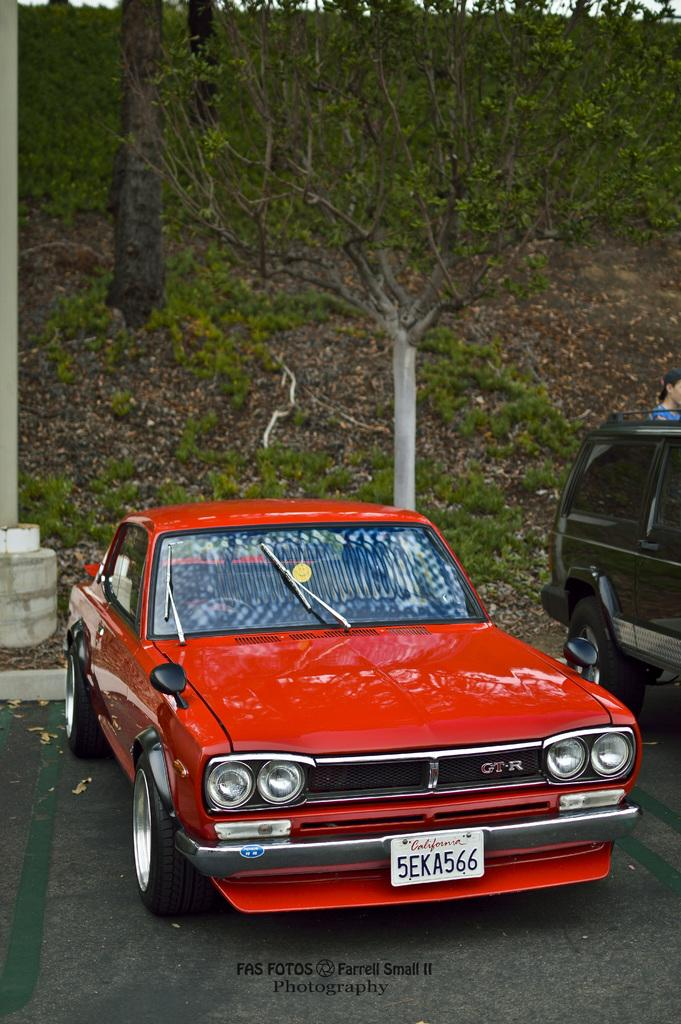What type of vehicle is in the image? There is a red color car in the image. Can you describe the car's color? The car is red. What can be seen in the background of the image? There are trees in the background of the image. What is present at the bottom of the image? There are plants at the bottom of the image. Is there a person visible in the image? Yes, there is a person on the right side of the image. What type of turkey is being prepared by the person on the right side of the image? There is no turkey present in the image; it features a red color car, trees, plants, and a person. What is the relationship between the person and the car in the image? The provided facts do not mention any relationship between the person and the car; we can only observe that the person is on the right side of the image. 